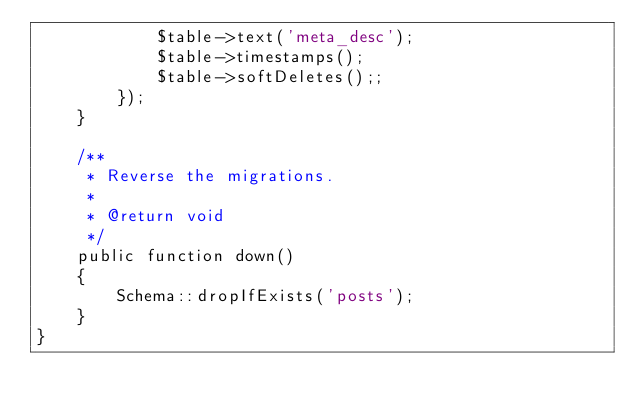<code> <loc_0><loc_0><loc_500><loc_500><_PHP_>            $table->text('meta_desc');
            $table->timestamps();
            $table->softDeletes();;
        });
    }

    /**
     * Reverse the migrations.
     *
     * @return void
     */
    public function down()
    {
        Schema::dropIfExists('posts');
    }
}
</code> 